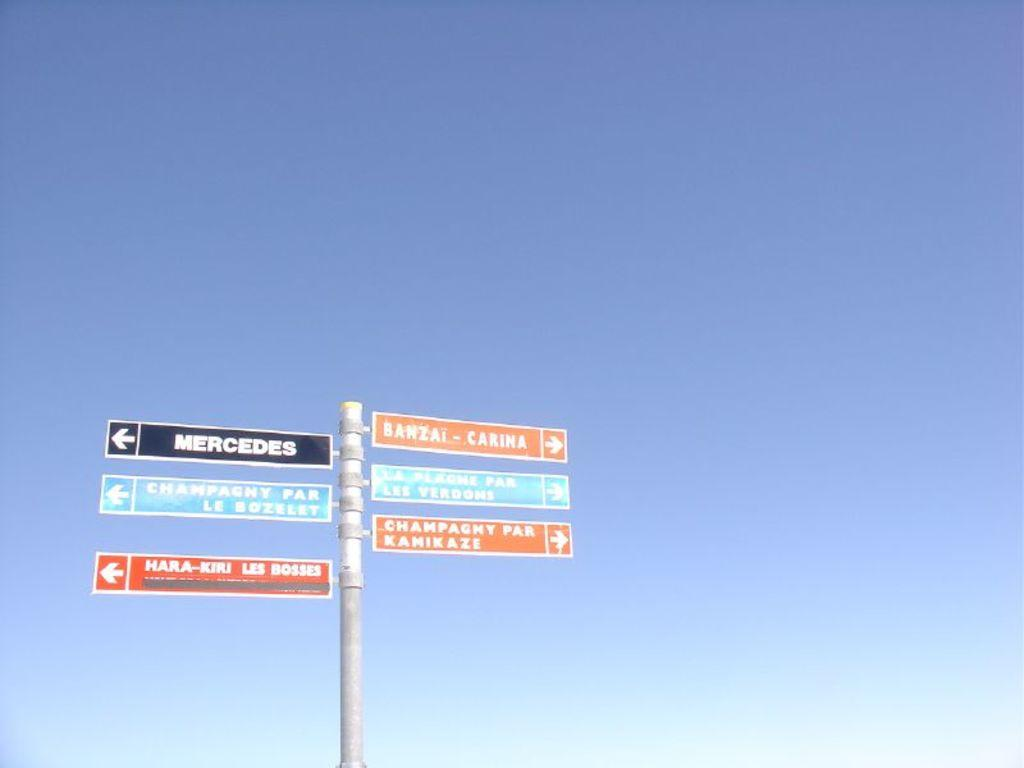<image>
Create a compact narrative representing the image presented. A pole has several signs on it, including one that says "Mercedes." 